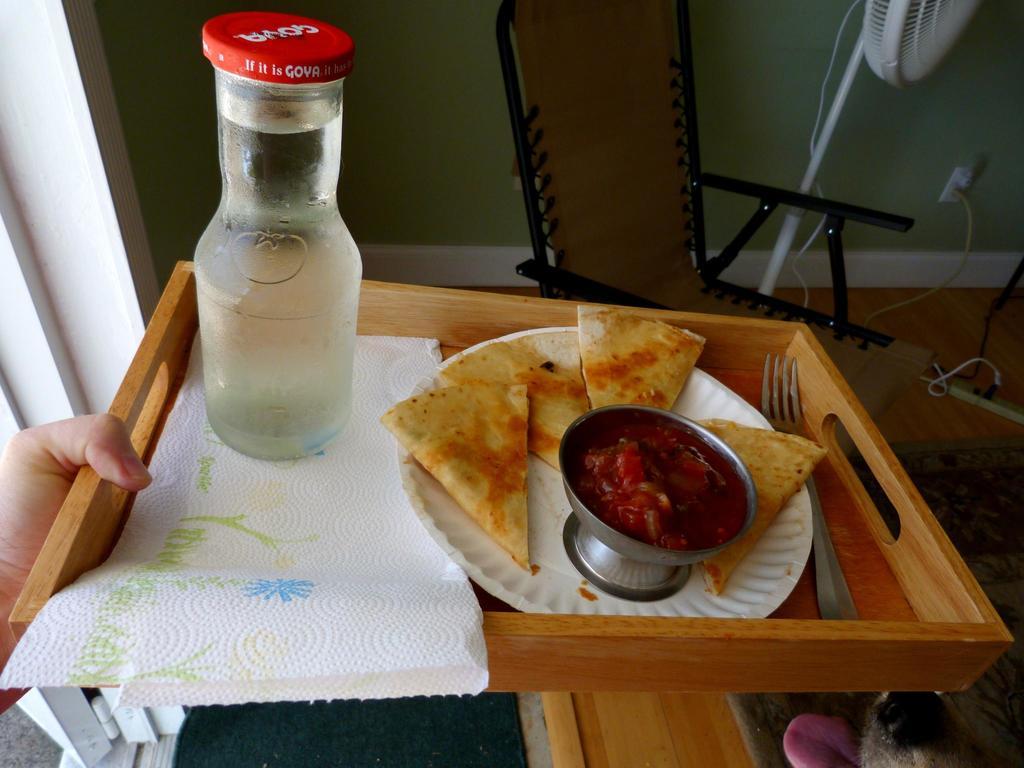Is the bottle goya?
Give a very brief answer. Yes. 